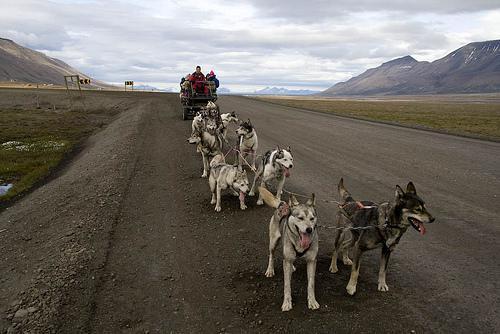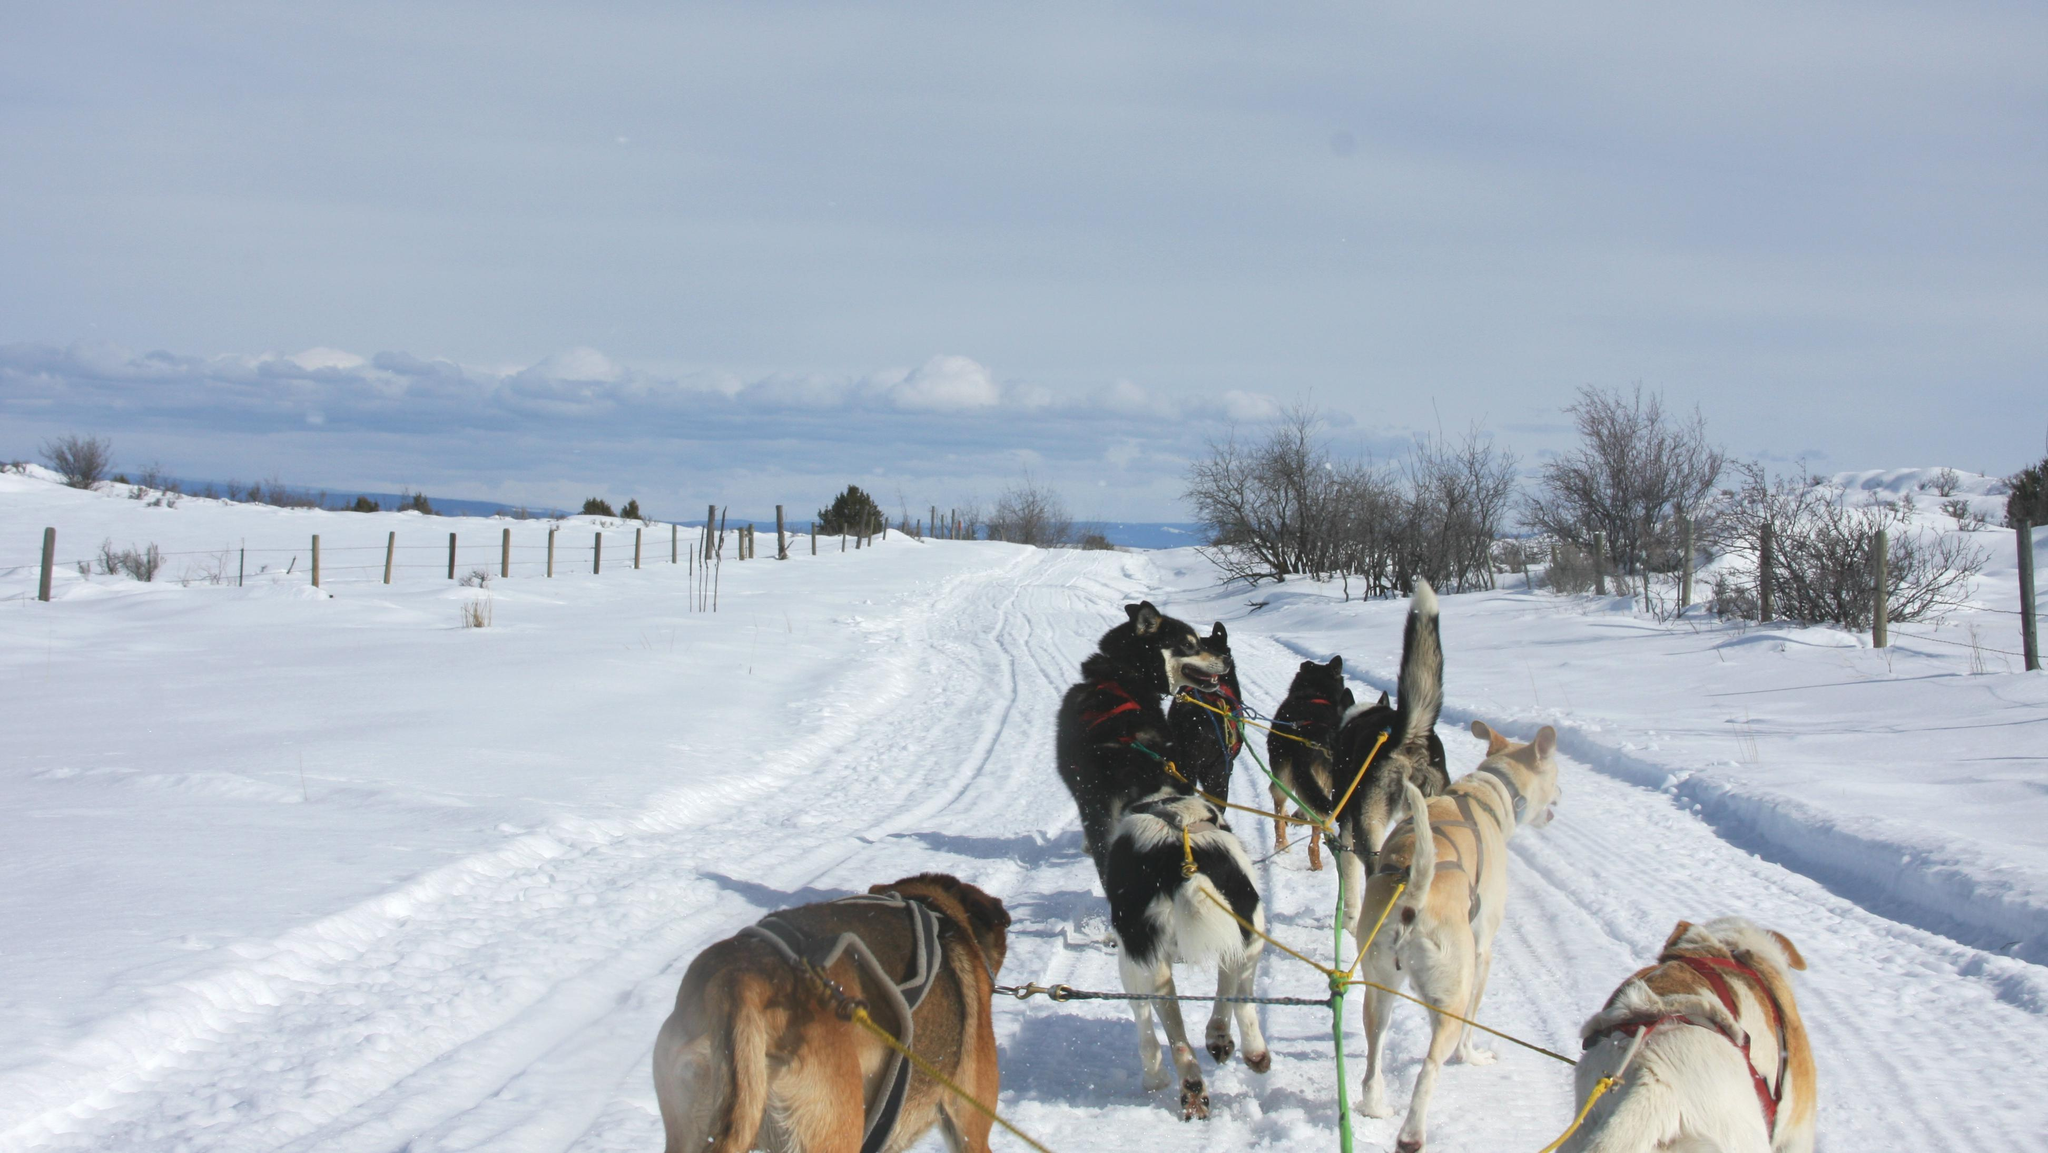The first image is the image on the left, the second image is the image on the right. For the images shown, is this caption "The image on the left shows a dog team running in snow." true? Answer yes or no. No. The first image is the image on the left, the second image is the image on the right. Given the left and right images, does the statement "One dog team is crossing snowy ground while the other is hitched to a wheeled cart on a dry road." hold true? Answer yes or no. Yes. 